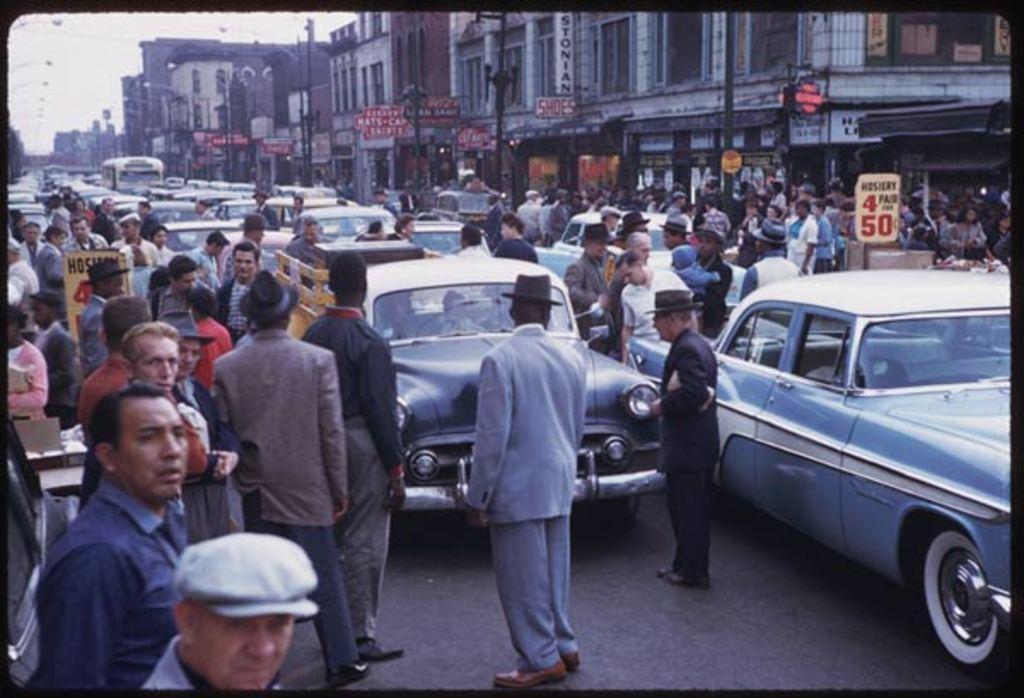Can you describe this image briefly? This image is clicked on the road. There are many cars on the road. There are many people standing on the road. To the right there are buildings. There are boards with text on the walls of the buildings. In front of the buildings there are sign board poles and street light poles. In the top left there is the sky. 